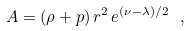<formula> <loc_0><loc_0><loc_500><loc_500>A = ( \rho + p ) \, r ^ { 2 } \, e ^ { ( \nu - \lambda ) / 2 } \ ,</formula> 